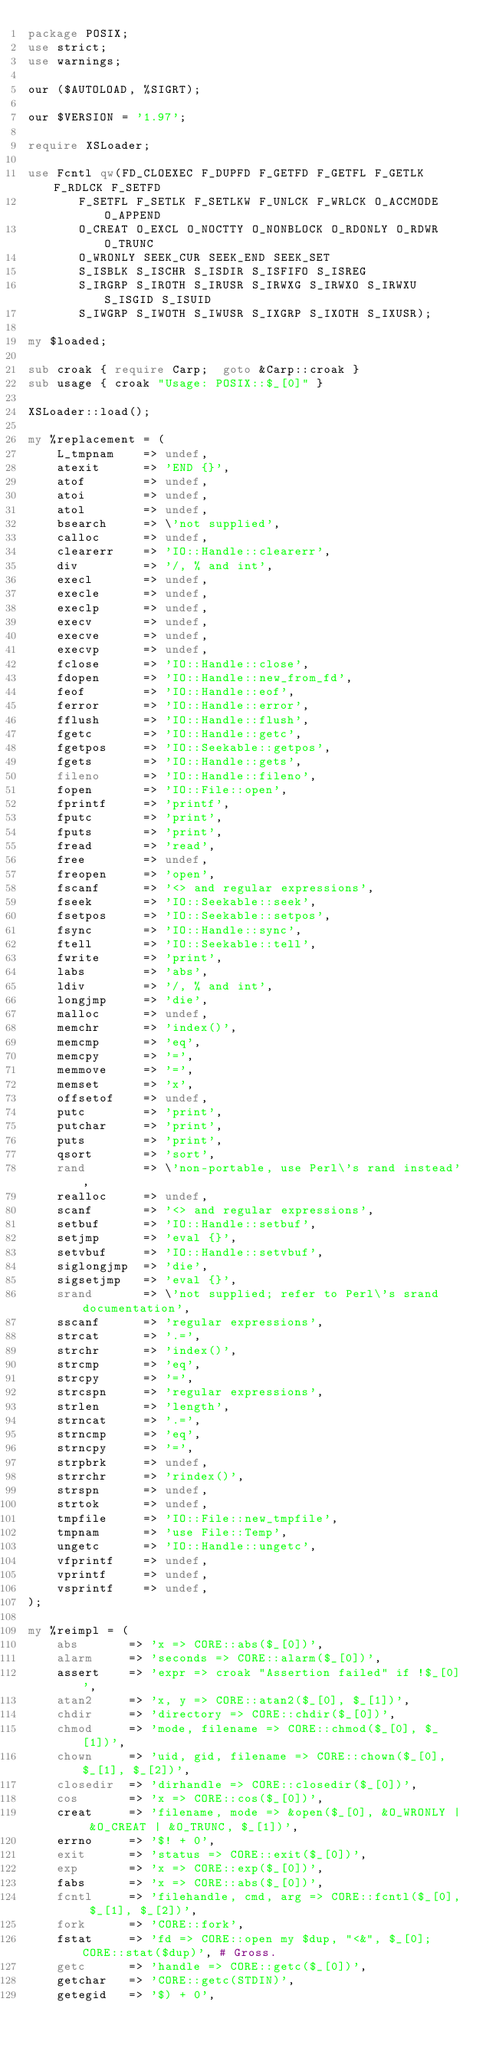<code> <loc_0><loc_0><loc_500><loc_500><_Perl_>package POSIX;
use strict;
use warnings;

our ($AUTOLOAD, %SIGRT);

our $VERSION = '1.97';

require XSLoader;

use Fcntl qw(FD_CLOEXEC F_DUPFD F_GETFD F_GETFL F_GETLK F_RDLCK F_SETFD
	     F_SETFL F_SETLK F_SETLKW F_UNLCK F_WRLCK O_ACCMODE O_APPEND
	     O_CREAT O_EXCL O_NOCTTY O_NONBLOCK O_RDONLY O_RDWR O_TRUNC
	     O_WRONLY SEEK_CUR SEEK_END SEEK_SET
	     S_ISBLK S_ISCHR S_ISDIR S_ISFIFO S_ISREG
	     S_IRGRP S_IROTH S_IRUSR S_IRWXG S_IRWXO S_IRWXU S_ISGID S_ISUID
	     S_IWGRP S_IWOTH S_IWUSR S_IXGRP S_IXOTH S_IXUSR);

my $loaded;

sub croak { require Carp;  goto &Carp::croak }
sub usage { croak "Usage: POSIX::$_[0]" }

XSLoader::load();

my %replacement = (
    L_tmpnam    => undef,
    atexit      => 'END {}',
    atof        => undef,
    atoi        => undef,
    atol        => undef,
    bsearch     => \'not supplied',
    calloc      => undef,
    clearerr    => 'IO::Handle::clearerr',
    div         => '/, % and int',
    execl       => undef,
    execle      => undef,
    execlp      => undef,
    execv       => undef,
    execve      => undef,
    execvp      => undef,
    fclose      => 'IO::Handle::close',
    fdopen      => 'IO::Handle::new_from_fd',
    feof        => 'IO::Handle::eof',
    ferror      => 'IO::Handle::error',
    fflush      => 'IO::Handle::flush',
    fgetc       => 'IO::Handle::getc',
    fgetpos     => 'IO::Seekable::getpos',
    fgets       => 'IO::Handle::gets',
    fileno      => 'IO::Handle::fileno',
    fopen       => 'IO::File::open',
    fprintf     => 'printf',
    fputc       => 'print',
    fputs       => 'print',
    fread       => 'read',
    free        => undef,
    freopen     => 'open',
    fscanf      => '<> and regular expressions',
    fseek       => 'IO::Seekable::seek',
    fsetpos     => 'IO::Seekable::setpos',
    fsync       => 'IO::Handle::sync',
    ftell       => 'IO::Seekable::tell',
    fwrite      => 'print',
    labs        => 'abs',
    ldiv        => '/, % and int',
    longjmp     => 'die',
    malloc      => undef,
    memchr      => 'index()',
    memcmp      => 'eq',
    memcpy      => '=',
    memmove     => '=',
    memset      => 'x',
    offsetof    => undef,
    putc        => 'print',
    putchar     => 'print',
    puts        => 'print',
    qsort       => 'sort',
    rand        => \'non-portable, use Perl\'s rand instead',
    realloc     => undef,
    scanf       => '<> and regular expressions',
    setbuf      => 'IO::Handle::setbuf',
    setjmp      => 'eval {}',
    setvbuf     => 'IO::Handle::setvbuf',
    siglongjmp  => 'die',
    sigsetjmp   => 'eval {}',
    srand       => \'not supplied; refer to Perl\'s srand documentation',
    sscanf      => 'regular expressions',
    strcat      => '.=',
    strchr      => 'index()',
    strcmp      => 'eq',
    strcpy      => '=',
    strcspn     => 'regular expressions',
    strlen      => 'length',
    strncat     => '.=',
    strncmp     => 'eq',
    strncpy     => '=',
    strpbrk     => undef,
    strrchr     => 'rindex()',
    strspn      => undef,
    strtok      => undef,
    tmpfile     => 'IO::File::new_tmpfile',
    tmpnam      => 'use File::Temp',
    ungetc      => 'IO::Handle::ungetc',
    vfprintf    => undef,
    vprintf     => undef,
    vsprintf    => undef,
);

my %reimpl = (
    abs       => 'x => CORE::abs($_[0])',
    alarm     => 'seconds => CORE::alarm($_[0])',
    assert    => 'expr => croak "Assertion failed" if !$_[0]',
    atan2     => 'x, y => CORE::atan2($_[0], $_[1])',
    chdir     => 'directory => CORE::chdir($_[0])',
    chmod     => 'mode, filename => CORE::chmod($_[0], $_[1])',
    chown     => 'uid, gid, filename => CORE::chown($_[0], $_[1], $_[2])',
    closedir  => 'dirhandle => CORE::closedir($_[0])',
    cos       => 'x => CORE::cos($_[0])',
    creat     => 'filename, mode => &open($_[0], &O_WRONLY | &O_CREAT | &O_TRUNC, $_[1])',
    errno     => '$! + 0',
    exit      => 'status => CORE::exit($_[0])',
    exp       => 'x => CORE::exp($_[0])',
    fabs      => 'x => CORE::abs($_[0])',
    fcntl     => 'filehandle, cmd, arg => CORE::fcntl($_[0], $_[1], $_[2])',
    fork      => 'CORE::fork',
    fstat     => 'fd => CORE::open my $dup, "<&", $_[0]; CORE::stat($dup)', # Gross.
    getc      => 'handle => CORE::getc($_[0])',
    getchar   => 'CORE::getc(STDIN)',
    getegid   => '$) + 0',</code> 